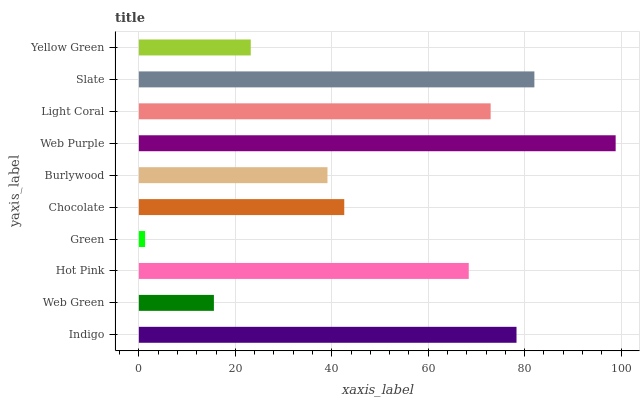Is Green the minimum?
Answer yes or no. Yes. Is Web Purple the maximum?
Answer yes or no. Yes. Is Web Green the minimum?
Answer yes or no. No. Is Web Green the maximum?
Answer yes or no. No. Is Indigo greater than Web Green?
Answer yes or no. Yes. Is Web Green less than Indigo?
Answer yes or no. Yes. Is Web Green greater than Indigo?
Answer yes or no. No. Is Indigo less than Web Green?
Answer yes or no. No. Is Hot Pink the high median?
Answer yes or no. Yes. Is Chocolate the low median?
Answer yes or no. Yes. Is Burlywood the high median?
Answer yes or no. No. Is Indigo the low median?
Answer yes or no. No. 